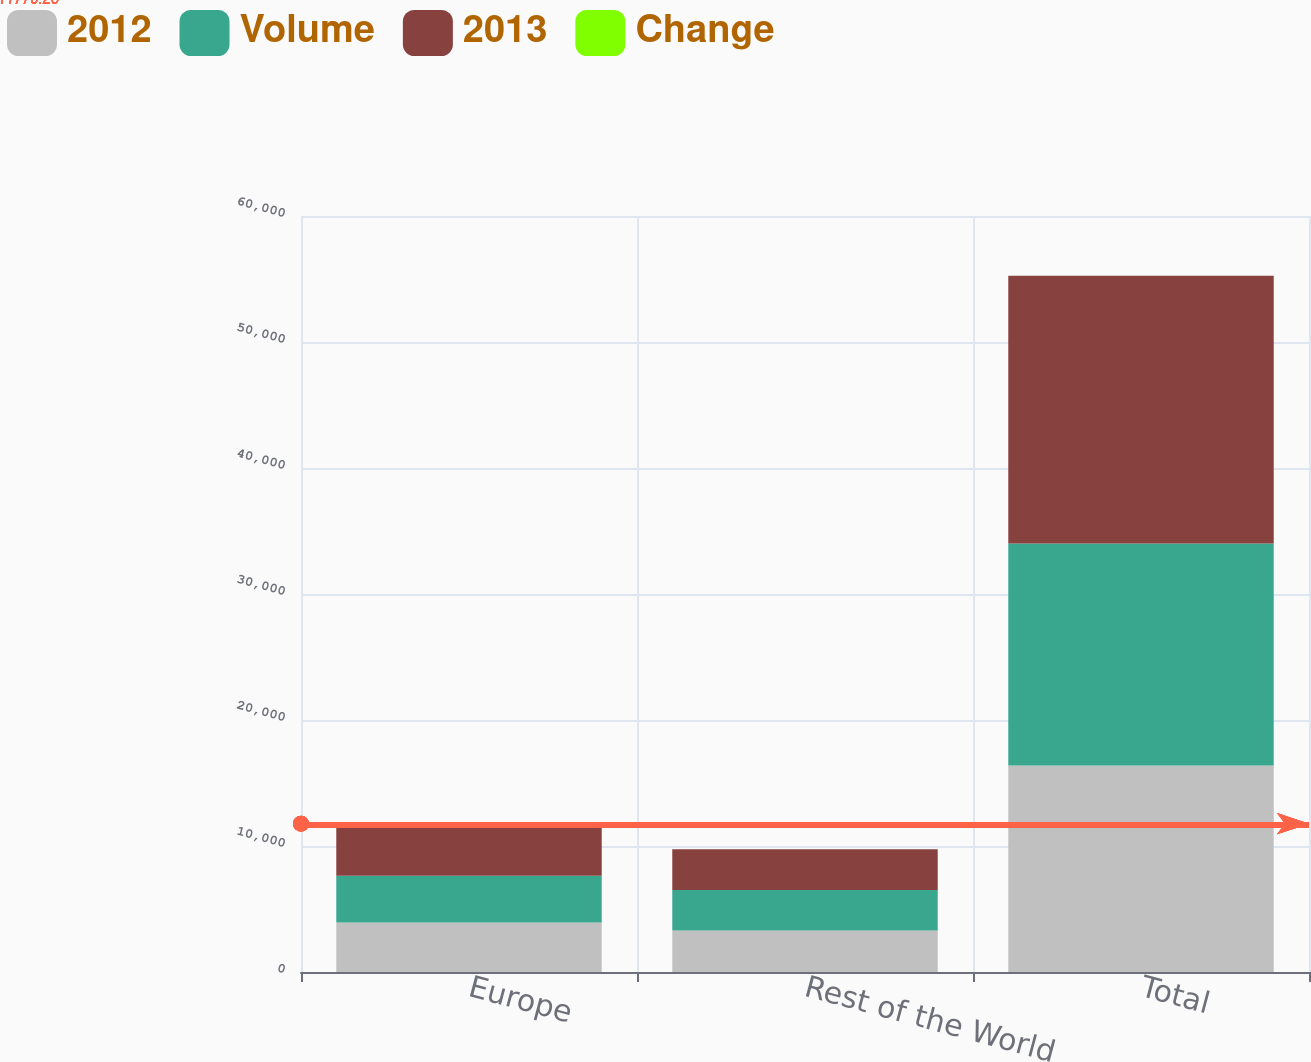Convert chart. <chart><loc_0><loc_0><loc_500><loc_500><stacked_bar_chart><ecel><fcel>Europe<fcel>Rest of the World<fcel>Total<nl><fcel>2012<fcel>3930<fcel>3295<fcel>16385<nl><fcel>Volume<fcel>3706<fcel>3204<fcel>17621<nl><fcel>2013<fcel>3879<fcel>3237<fcel>21244<nl><fcel>Change<fcel>6<fcel>3<fcel>7<nl></chart> 